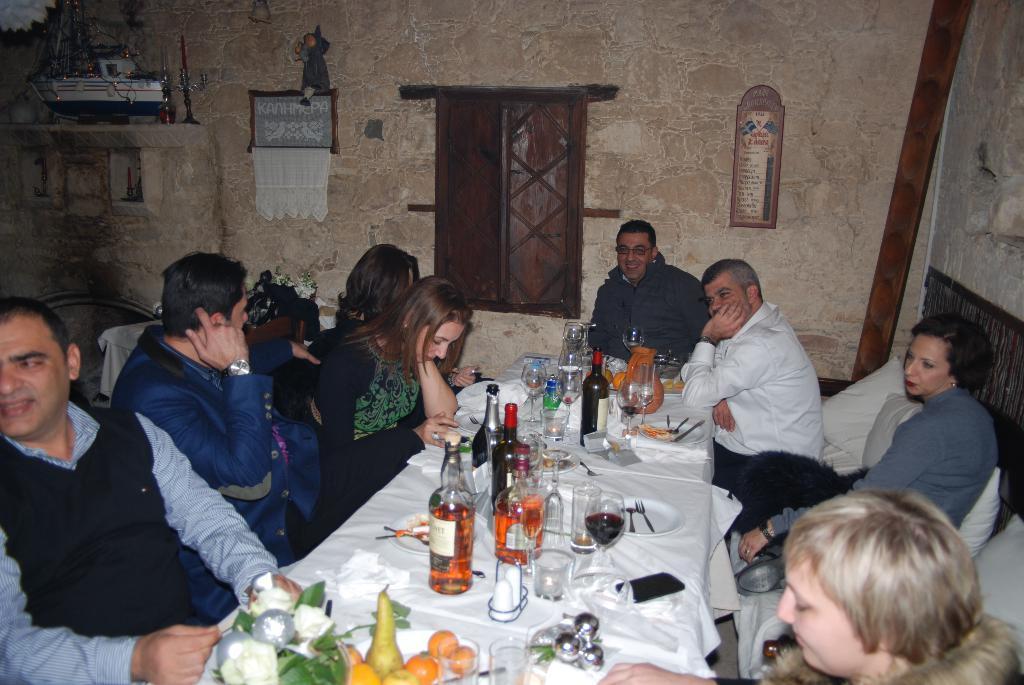Could you give a brief overview of what you see in this image? This picture shows a people sitting around a table in their chairs on which some glasses, bottles, forks, mobiles were placed along with some food items. In the background there is a wall and a window here. 